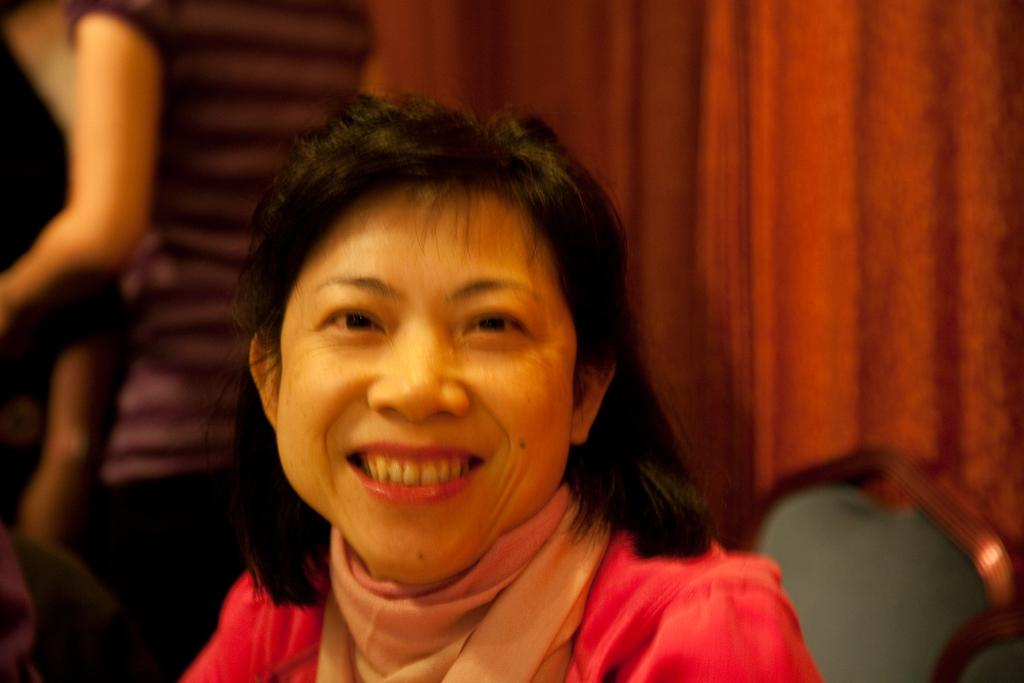What is the main subject of the image? The main subject of the image is a group of people. Can you describe the position of one of the individuals in the group? There is a woman sitting on a chair in the image. What type of window treatment is visible in the image? The curtains are visible at the top of the image. How many rays of sunshine can be seen on the woman's face in the image? There are no rays of sunshine visible on the woman's face in the image. Can you describe the type of kiss the woman is giving in the image? There is no kiss depicted in the image; it features a group of people and a woman sitting on a chair. 